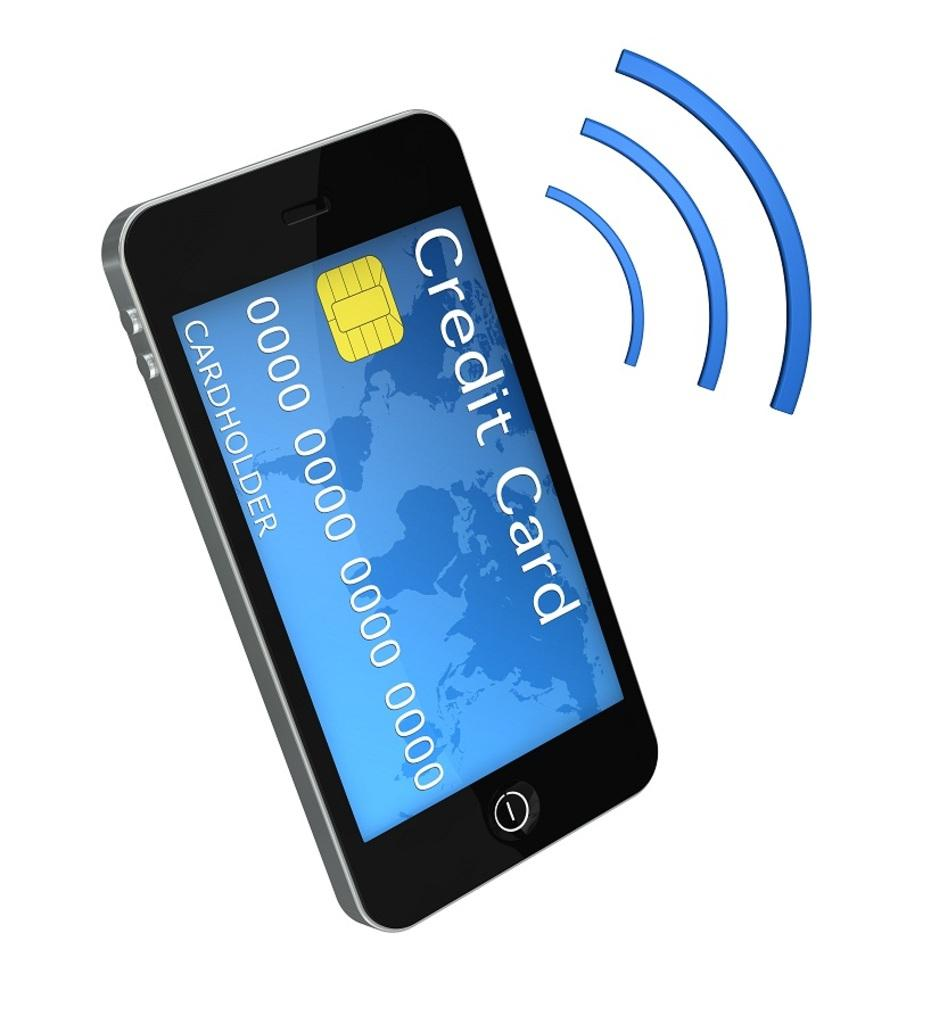Provide a one-sentence caption for the provided image. A phone that has a Credit Card on the screen and blue arced lines next to it. 